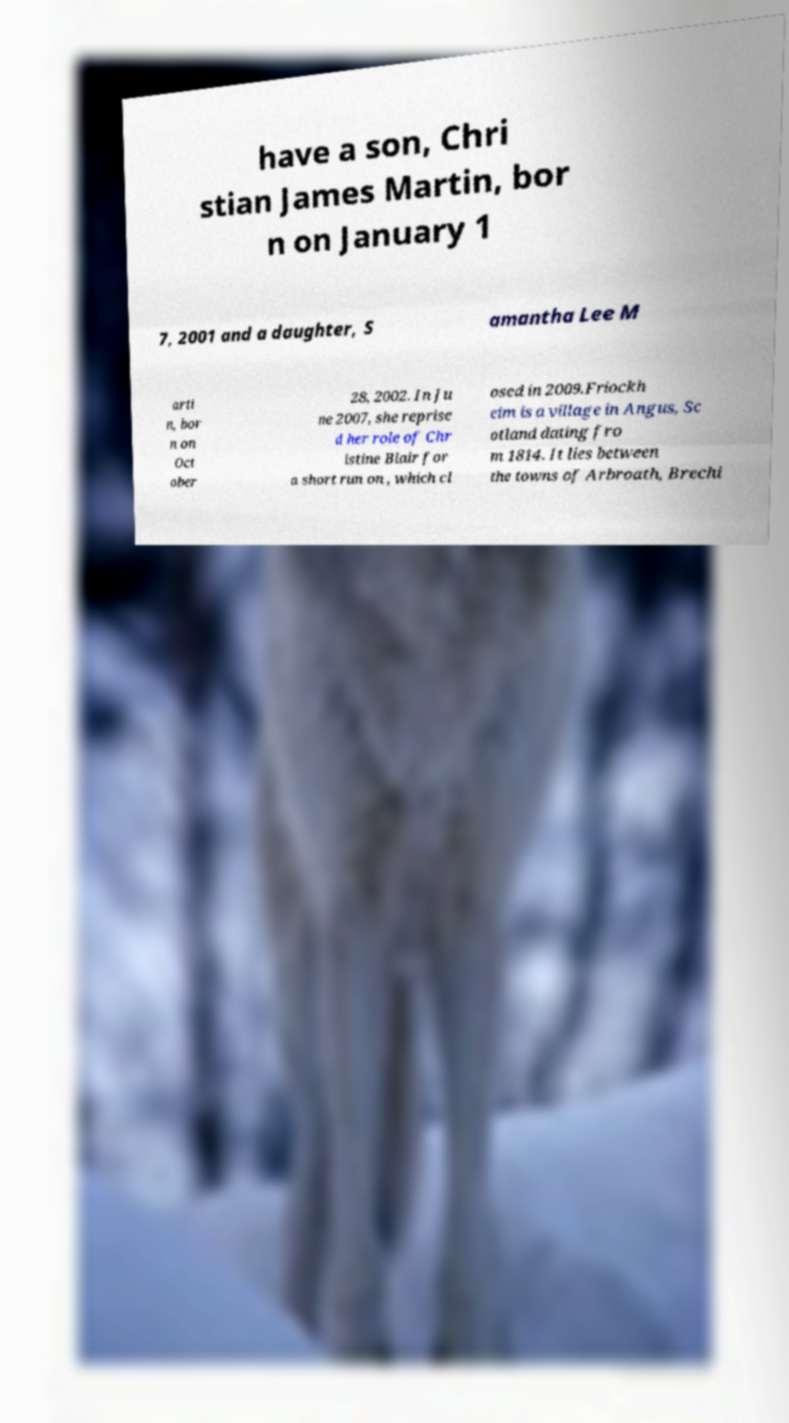Can you accurately transcribe the text from the provided image for me? have a son, Chri stian James Martin, bor n on January 1 7, 2001 and a daughter, S amantha Lee M arti n, bor n on Oct ober 28, 2002. In Ju ne 2007, she reprise d her role of Chr istine Blair for a short run on , which cl osed in 2009.Friockh eim is a village in Angus, Sc otland dating fro m 1814. It lies between the towns of Arbroath, Brechi 